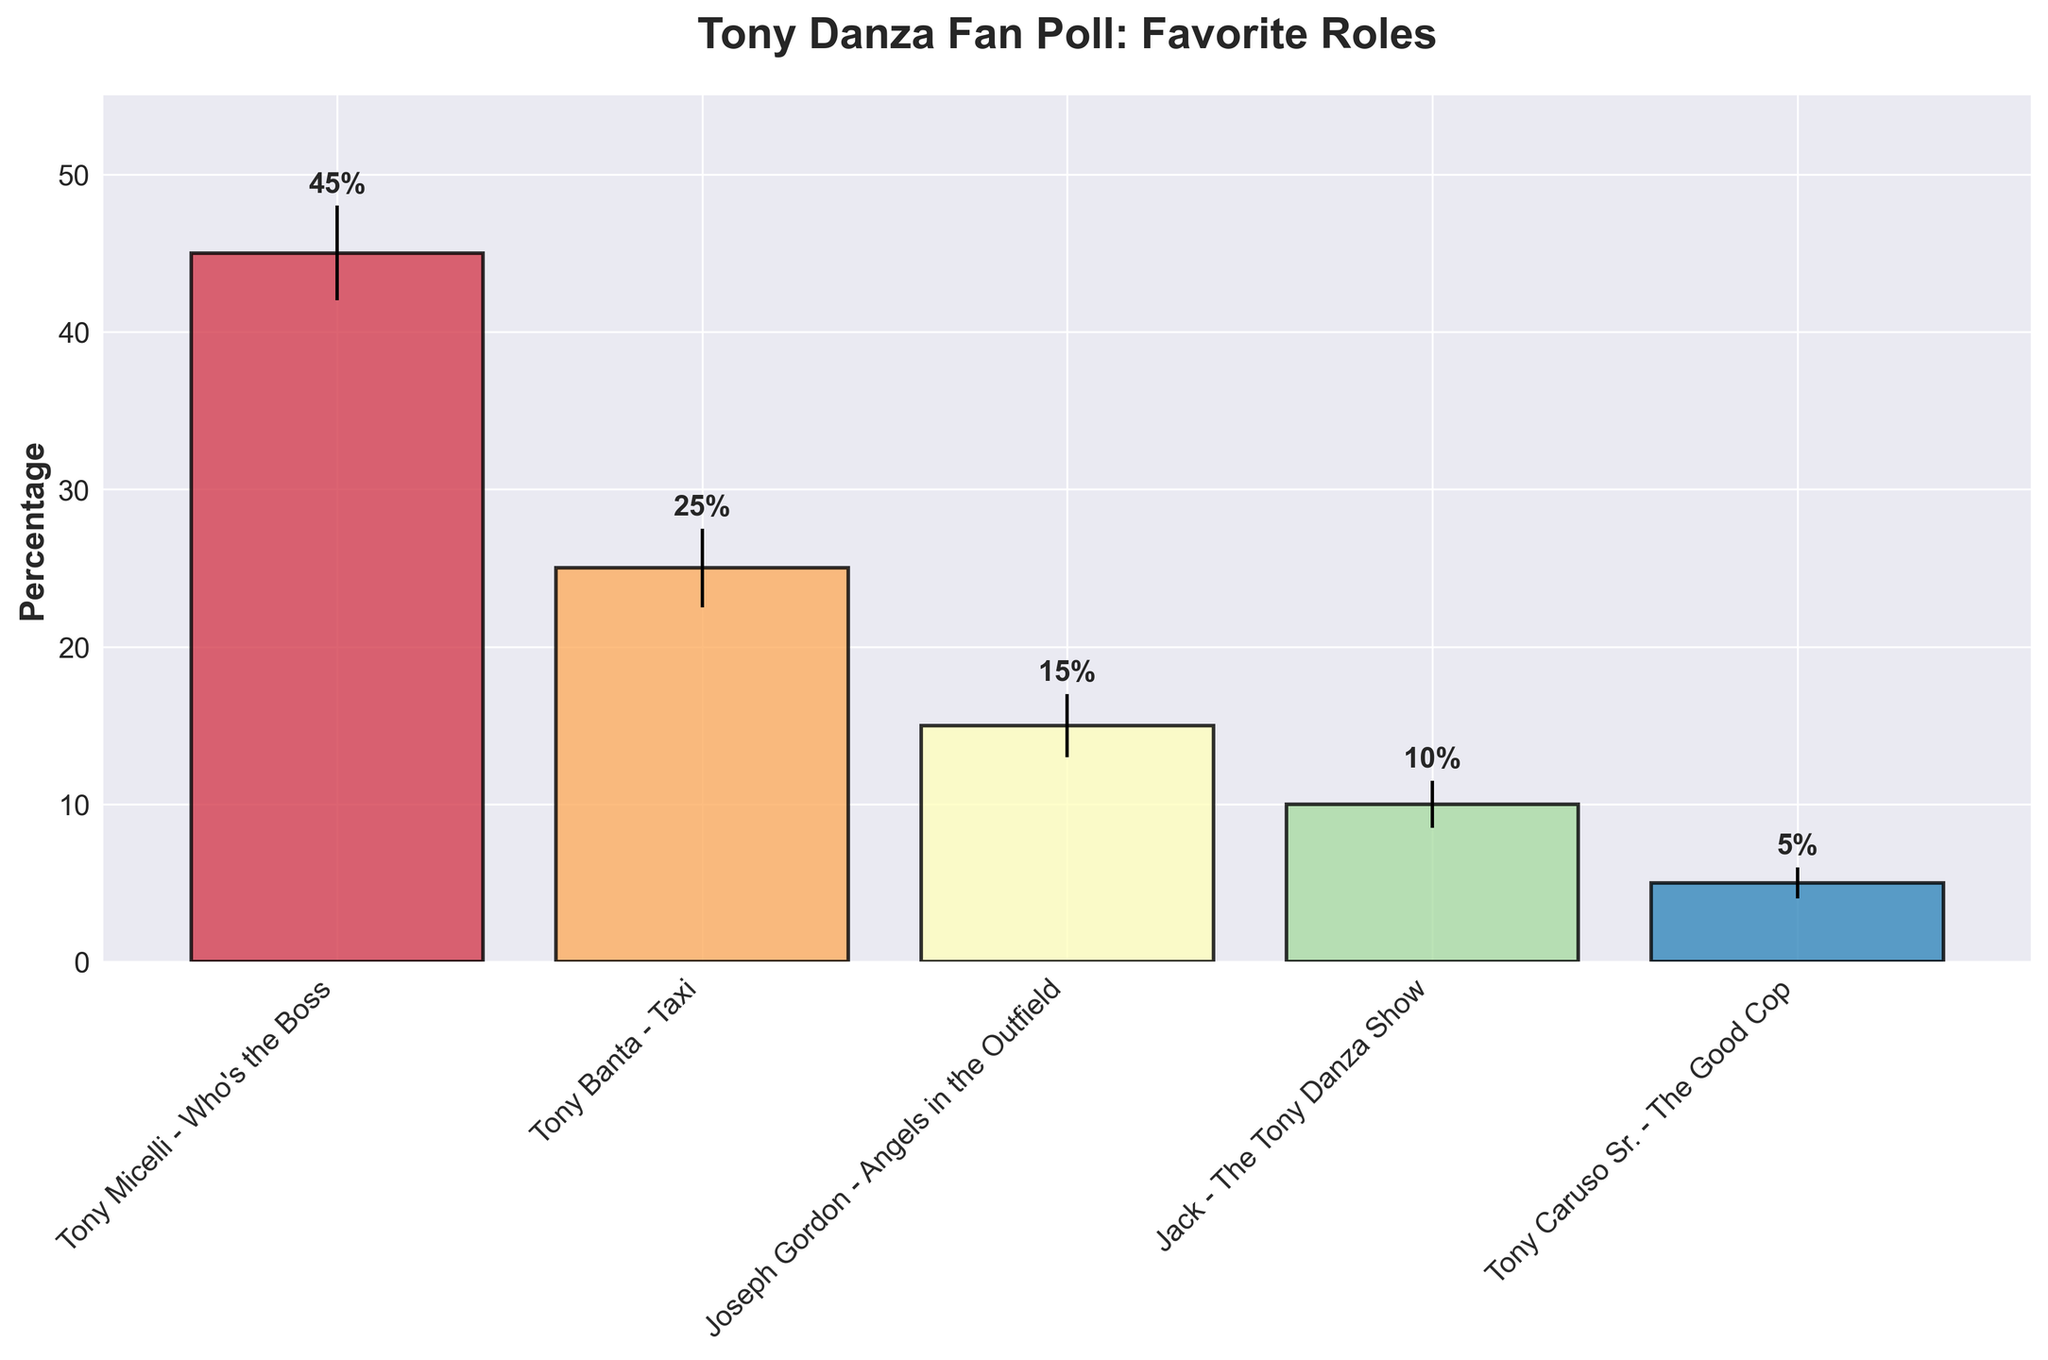What's the title of the chart? The title of the chart is located at the top and is displayed prominently in bold text, stating the subject of the chart to provide context for viewers.
Answer: Tony Danza Fan Poll: Favorite Roles Which role has the highest percentage of votes? By examining the height of the bars in the bar chart, the tallest bar corresponds to "Tony Micelli - Who's the Boss" which indicates the highest percentage of votes.
Answer: Tony Micelli - Who's the Boss What is the percentage of fans who favor Tony Banta from "Taxi"? Look at the label corresponding to "Tony Banta - Taxi" on the x-axis and read the height of the bar as well as the accompanying text.
Answer: 25% Which role has the smallest margin of error, and what is it? Observing the error bars on each bar: "Tony Caruso Sr. - The Good Cop" has the shortest error bar, signifying the smallest margin of error. The label reveals it as 1%.
Answer: Tony Caruso Sr. - The Good Cop, 1% What is the combined vote percentage for "Joseph Gordon - Angels in the Outfield" and "Jack - The Tony Danza Show"? Add the percentages for both roles: 15% (Joseph Gordon) + 10% (Jack) = 25%.
Answer: 25% Which role has a margin of error of 2.5%? Check the length of the error bars and their corresponding values, noting the role listed as 2.5%, which is "Tony Banta - Taxi".
Answer: Tony Banta - Taxi How much higher is the vote percentage for Tony Micelli compared to Tony Caruso Sr.? Subtract the percentage of Tony Caruso Sr. (5%) from Tony Micelli (45%): 45% - 5% = 40%.
Answer: 40% What is the range of the estimated percentage of fans favoring "Tony Micelli - Who's the Boss"? Incorporate the margin of error: Tony Micelli's percentage of 45% ± 3% gives a range from 42% to 48%.
Answer: 42% - 48% Which role has the closest vote percentage to 10%? Check the bar heights and their percentage labels, observing that "Jack - The Tony Danza Show" is exactly at 10%.
Answer: Jack - The Tony Danza Show 